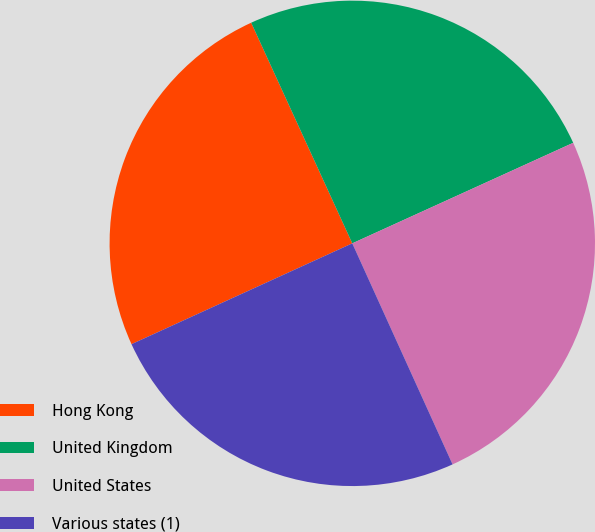<chart> <loc_0><loc_0><loc_500><loc_500><pie_chart><fcel>Hong Kong<fcel>United Kingdom<fcel>United States<fcel>Various states (1)<nl><fcel>24.98%<fcel>25.04%<fcel>25.02%<fcel>24.96%<nl></chart> 